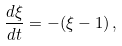<formula> <loc_0><loc_0><loc_500><loc_500>\frac { d \xi } { d t } = - ( \xi - 1 ) \, ,</formula> 